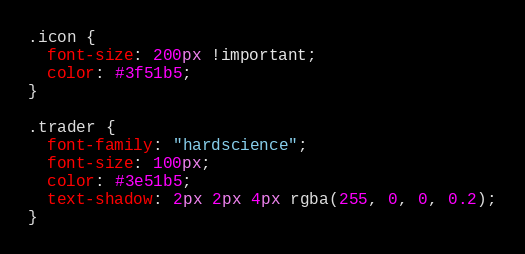<code> <loc_0><loc_0><loc_500><loc_500><_CSS_>
.icon {
  font-size: 200px !important;
  color: #3f51b5;
}

.trader {
  font-family: "hardscience";
  font-size: 100px;
  color: #3e51b5;
  text-shadow: 2px 2px 4px rgba(255, 0, 0, 0.2);
}
</code> 